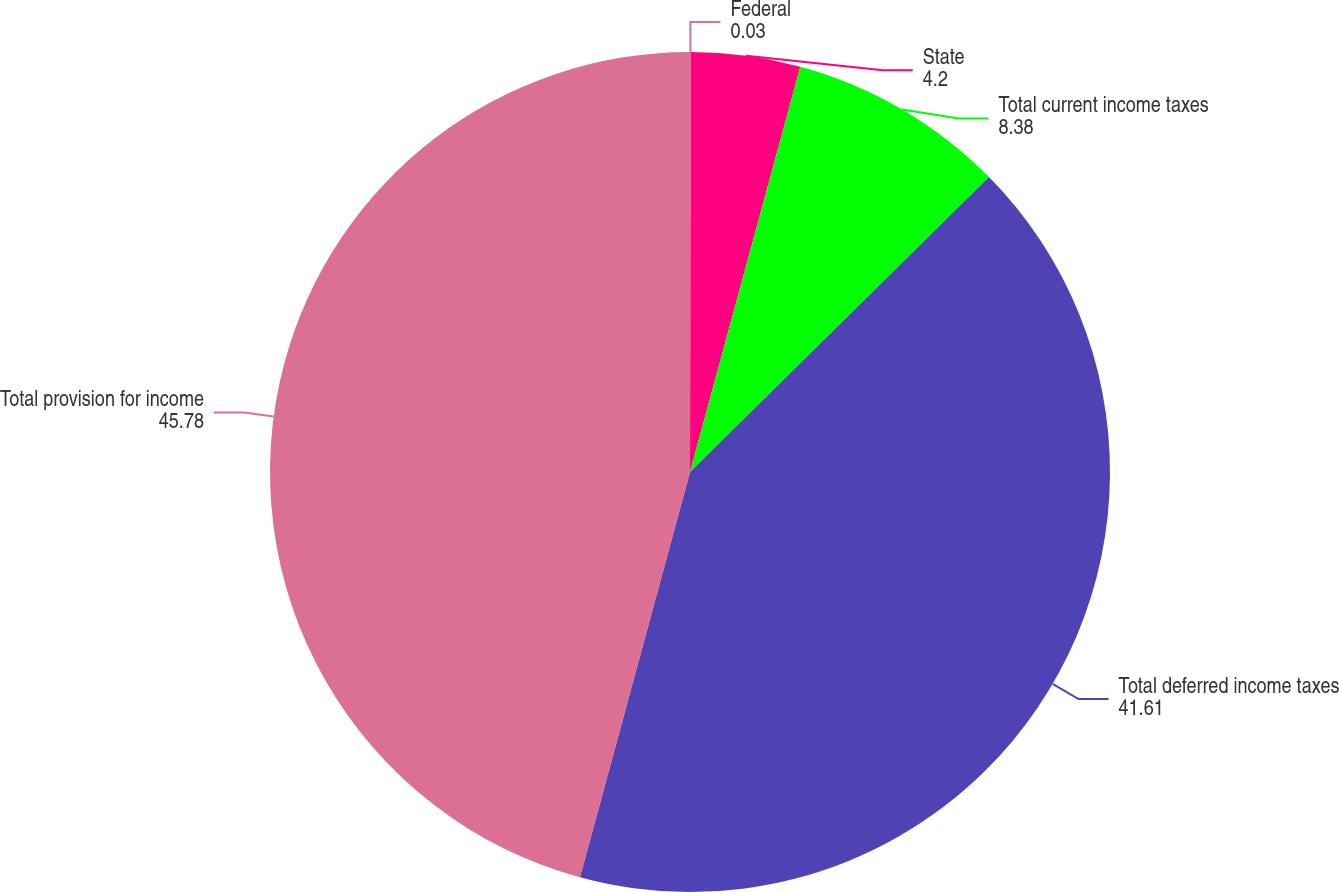Convert chart to OTSL. <chart><loc_0><loc_0><loc_500><loc_500><pie_chart><fcel>Federal<fcel>State<fcel>Total current income taxes<fcel>Total deferred income taxes<fcel>Total provision for income<nl><fcel>0.03%<fcel>4.2%<fcel>8.38%<fcel>41.61%<fcel>45.78%<nl></chart> 